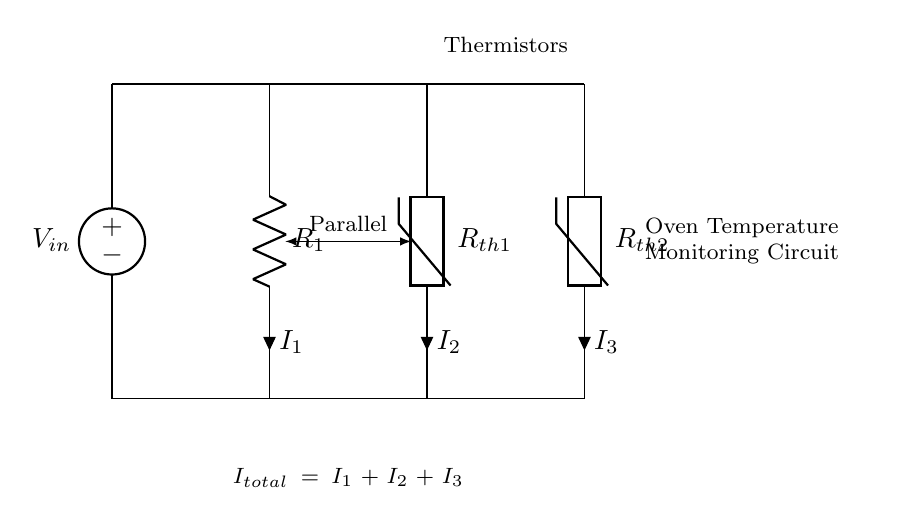What type of circuit is shown? The circuit is a parallel circuit, where components are connected across the same two points, allowing multiple paths for current.
Answer: Parallel What are the components present in the circuit? The components in the circuit include a voltage source, a resistor, and two thermistors. Each component has its designated label indicated in the diagram.
Answer: Voltage source, resistor, thermistors What does the total current formula symbolize? The formula indicates that the total current entering the junction (I total) is the sum of the currents through each of the parallel branches (I 1, I 2, I 3). This reflects the current divider rule.
Answer: I total = I 1 + I 2 + I 3 What does R 1 represent in the circuit? R 1 represents a resistor that may be used for current limiting or conditioning in conjunction with the thermistors, allowing for accurate temperature readings during baking.
Answer: Resistor If the thermistors are at different temperatures, how would that affect the current through each? The current through each thermistor changes based on its resistance, which varies with temperature; as one thermistor heats up and its resistance decreases, it allows more current to flow through it compared to the cooler thermistor.
Answer: Varies with temperature How many paths are available for current in this circuit? There are three paths available for the current to flow: one through the resistor and two through each of the thermistors, illustrating the nature of parallel circuits.
Answer: Three 